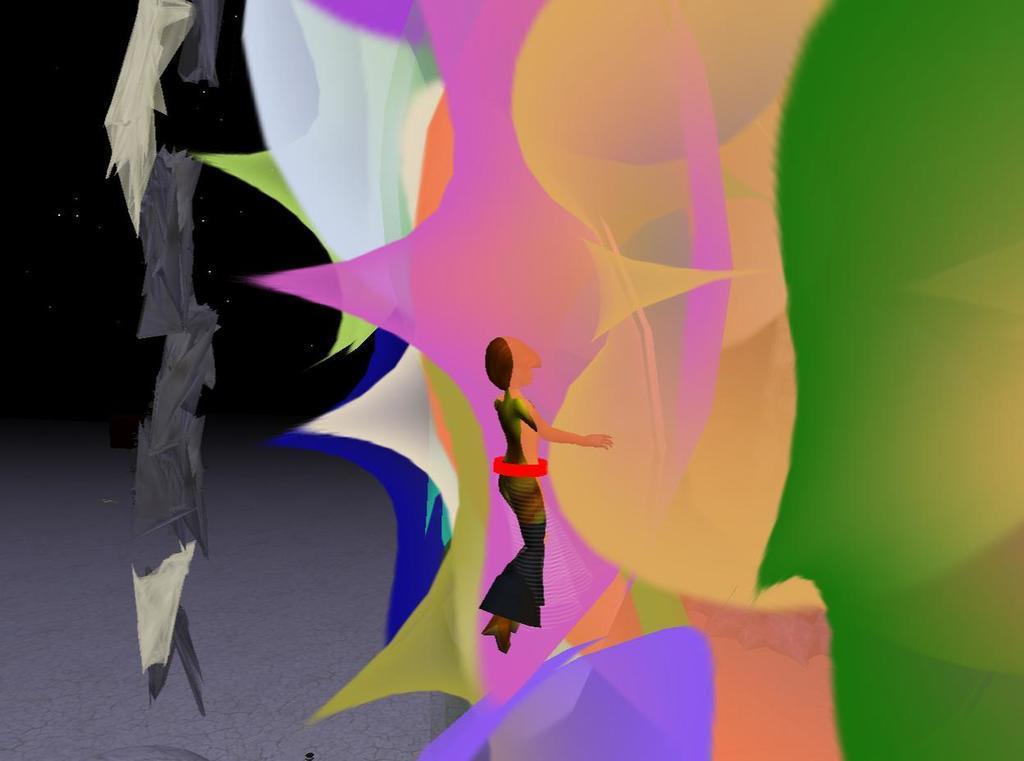Can you describe this image briefly? This is an animated image. In the image there are different shapes with different colors. And also there is an animated person.  